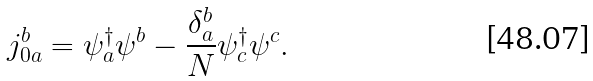Convert formula to latex. <formula><loc_0><loc_0><loc_500><loc_500>j ^ { b } _ { 0 a } = \psi ^ { \dagger } _ { a } \psi ^ { b } - \frac { \delta ^ { b } _ { a } } { N } \psi ^ { \dagger } _ { c } \psi ^ { c } .</formula> 